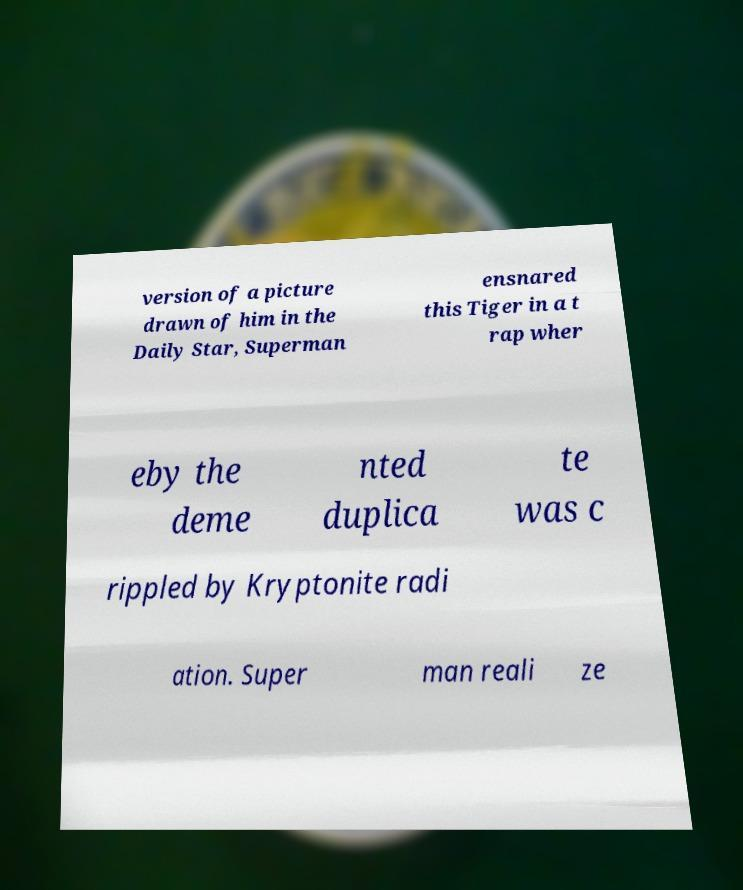Please read and relay the text visible in this image. What does it say? version of a picture drawn of him in the Daily Star, Superman ensnared this Tiger in a t rap wher eby the deme nted duplica te was c rippled by Kryptonite radi ation. Super man reali ze 